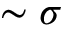<formula> <loc_0><loc_0><loc_500><loc_500>\sim \sigma</formula> 